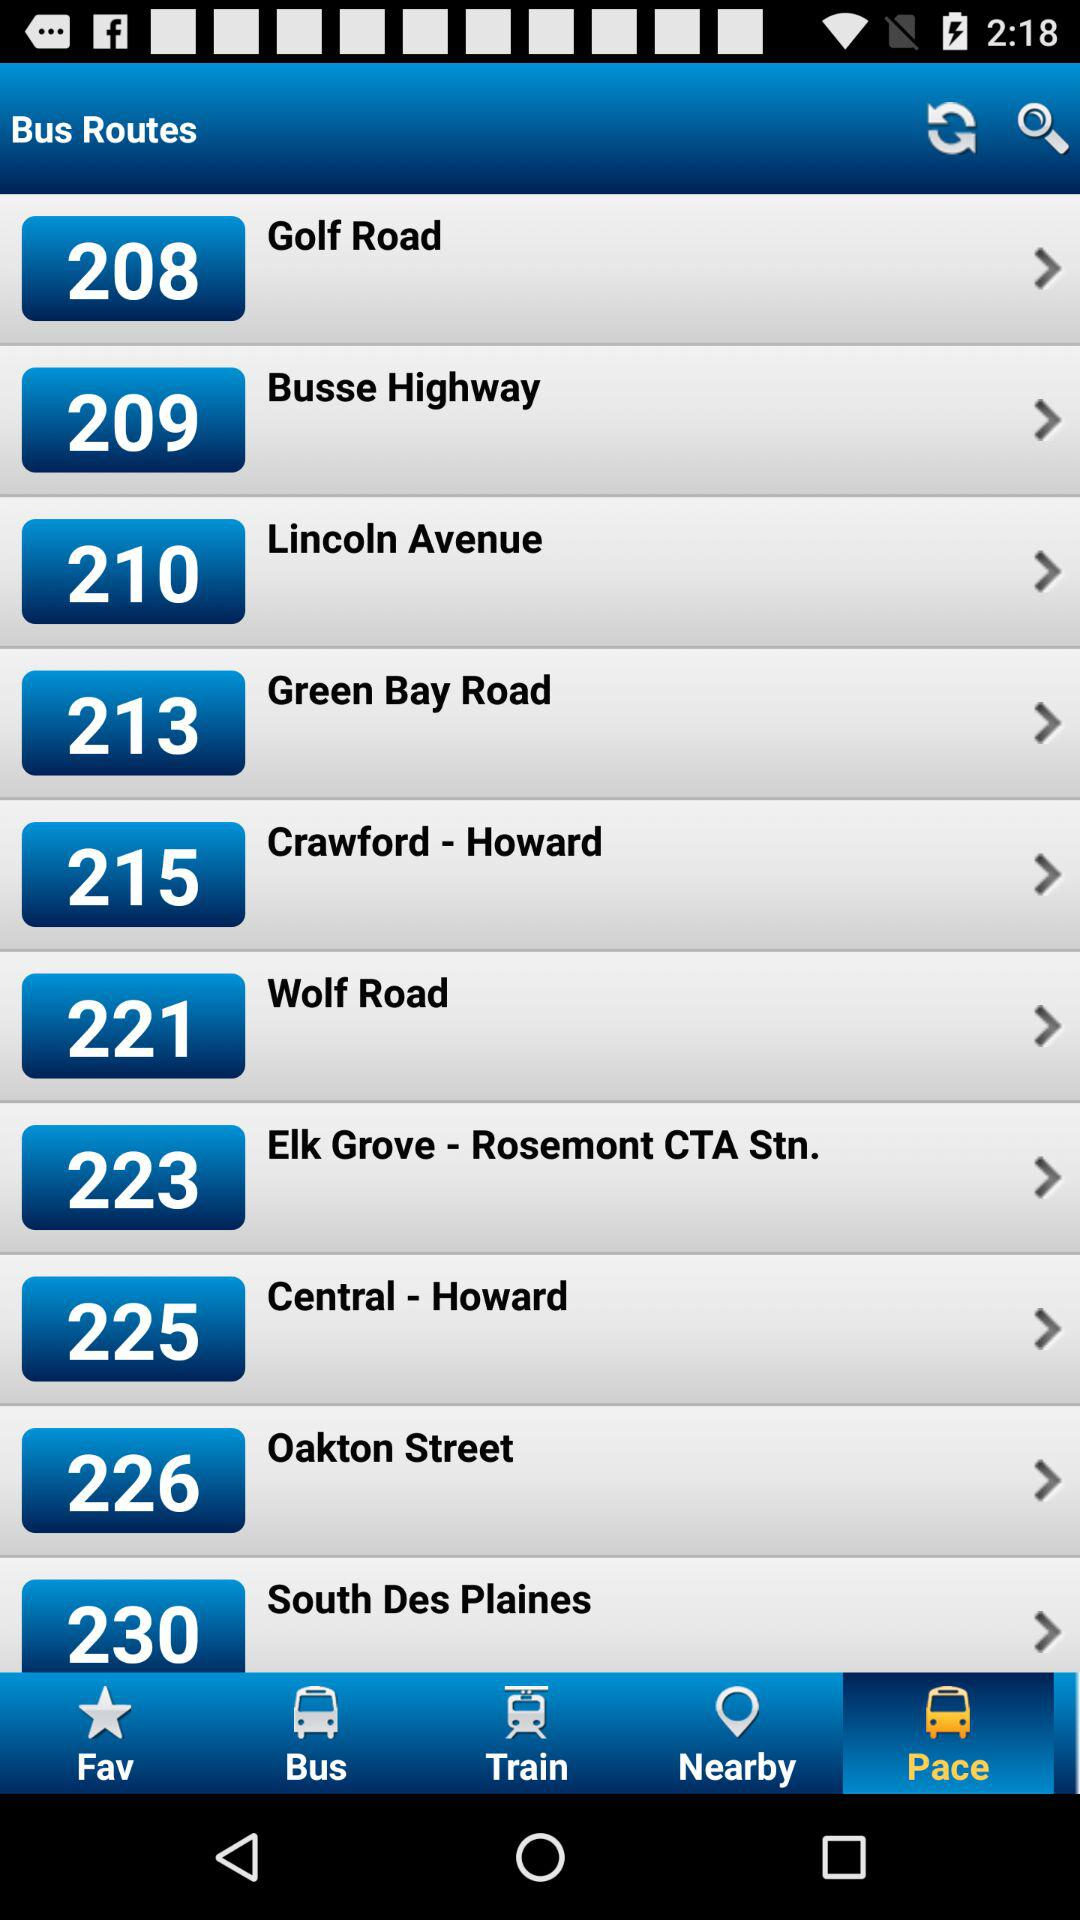Are there any accessibility options mentioned for these bus routes? The image does not explicitly mention any accessibility options for the bus routes. However, public transport authorities typically provide such information in a detailed route guide or on their official websites. 